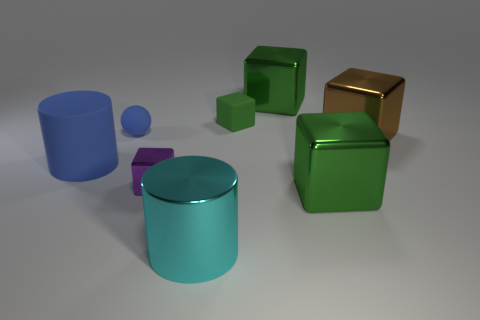There is a green rubber object that is the same shape as the big brown metal thing; what is its size?
Ensure brevity in your answer.  Small. There is a green thing that is both on the right side of the small green object and behind the tiny rubber ball; what material is it made of?
Offer a terse response. Metal. Is the number of green metal objects that are in front of the tiny blue matte sphere the same as the number of tiny purple things?
Make the answer very short. Yes. What number of objects are green metallic blocks that are in front of the brown cube or brown cubes?
Your answer should be very brief. 2. There is a small cube right of the purple shiny thing; does it have the same color as the big rubber cylinder?
Make the answer very short. No. How big is the block behind the matte block?
Offer a very short reply. Large. There is a large green object in front of the metallic object behind the blue sphere; what is its shape?
Provide a short and direct response. Cube. There is another tiny object that is the same shape as the purple metallic object; what color is it?
Ensure brevity in your answer.  Green. There is a cylinder that is in front of the blue cylinder; is it the same size as the brown shiny object?
Provide a short and direct response. Yes. There is a big rubber thing that is the same color as the rubber sphere; what shape is it?
Offer a very short reply. Cylinder. 